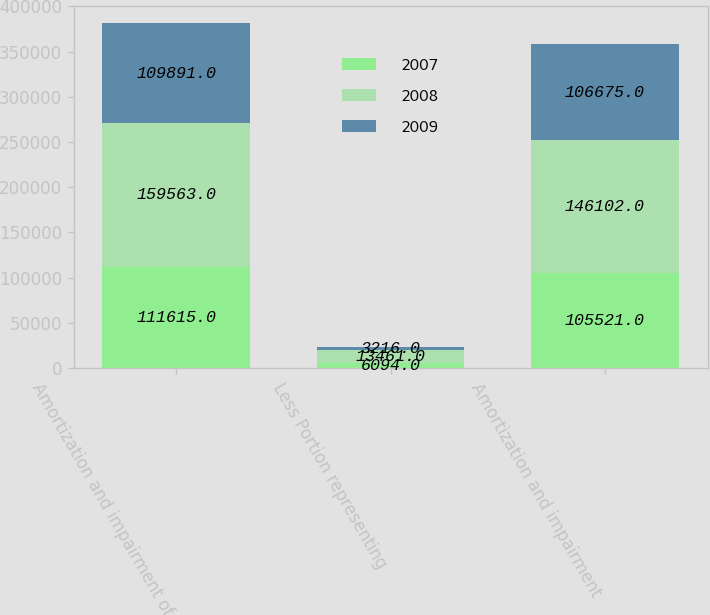<chart> <loc_0><loc_0><loc_500><loc_500><stacked_bar_chart><ecel><fcel>Amortization and impairment of<fcel>Less Portion representing<fcel>Amortization and impairment<nl><fcel>2007<fcel>111615<fcel>6094<fcel>105521<nl><fcel>2008<fcel>159563<fcel>13461<fcel>146102<nl><fcel>2009<fcel>109891<fcel>3216<fcel>106675<nl></chart> 